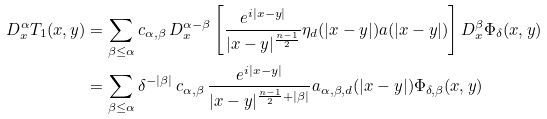Convert formula to latex. <formula><loc_0><loc_0><loc_500><loc_500>D ^ { \alpha } _ { x } T _ { 1 } ( x , y ) & = \sum _ { \beta \leq \alpha } c _ { \alpha , \beta } \, D ^ { \alpha - \beta } _ { x } \left [ \frac { e ^ { i | x - y | } } { | x - y | ^ { \frac { n - 1 } { 2 } } } \eta _ { d } ( | x - y | ) a ( | x - y | ) \right ] D ^ { \beta } _ { x } \Phi _ { \delta } ( x , y ) \\ & = \sum _ { \beta \leq \alpha } \delta ^ { - | \beta | } \, c _ { \alpha , \beta } \, \frac { e ^ { i | x - y | } } { | x - y | ^ { \frac { n - 1 } { 2 } + | \beta | } } a _ { \alpha , \beta , d } ( | x - y | ) \Phi _ { \delta , \beta } ( x , y )</formula> 